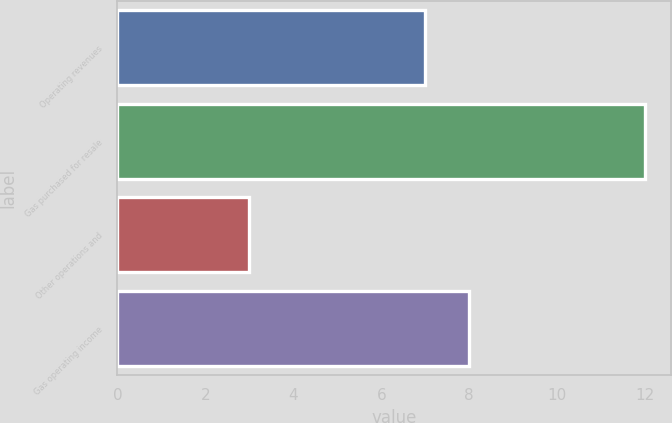Convert chart to OTSL. <chart><loc_0><loc_0><loc_500><loc_500><bar_chart><fcel>Operating revenues<fcel>Gas purchased for resale<fcel>Other operations and<fcel>Gas operating income<nl><fcel>7<fcel>12<fcel>3<fcel>8<nl></chart> 